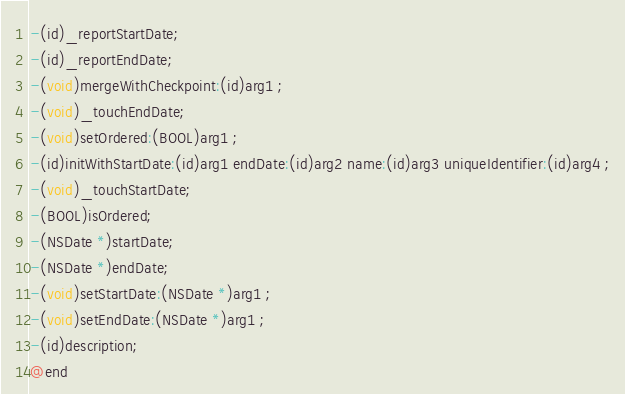Convert code to text. <code><loc_0><loc_0><loc_500><loc_500><_C_>-(id)_reportStartDate;
-(id)_reportEndDate;
-(void)mergeWithCheckpoint:(id)arg1 ;
-(void)_touchEndDate;
-(void)setOrdered:(BOOL)arg1 ;
-(id)initWithStartDate:(id)arg1 endDate:(id)arg2 name:(id)arg3 uniqueIdentifier:(id)arg4 ;
-(void)_touchStartDate;
-(BOOL)isOrdered;
-(NSDate *)startDate;
-(NSDate *)endDate;
-(void)setStartDate:(NSDate *)arg1 ;
-(void)setEndDate:(NSDate *)arg1 ;
-(id)description;
@end

</code> 